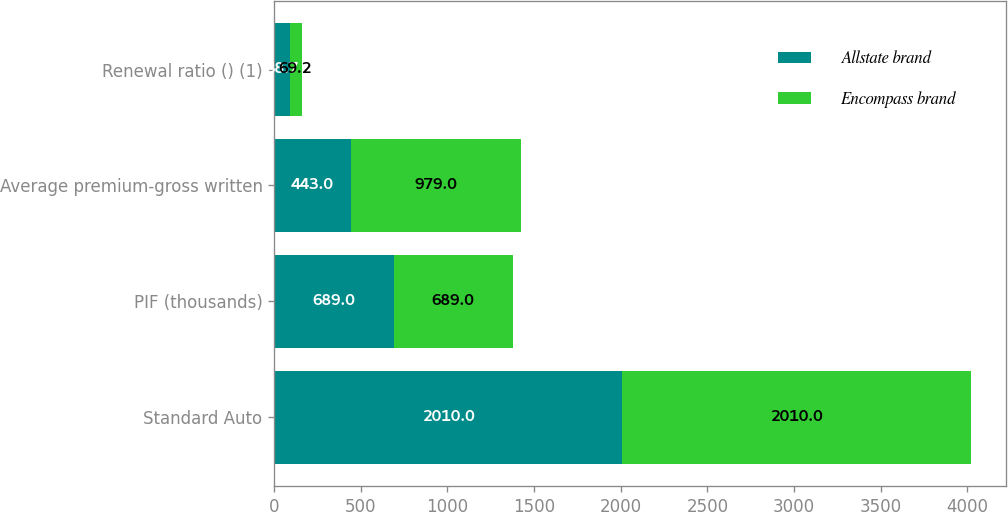<chart> <loc_0><loc_0><loc_500><loc_500><stacked_bar_chart><ecel><fcel>Standard Auto<fcel>PIF (thousands)<fcel>Average premium-gross written<fcel>Renewal ratio () (1)<nl><fcel>Allstate brand<fcel>2010<fcel>689<fcel>443<fcel>88.7<nl><fcel>Encompass brand<fcel>2010<fcel>689<fcel>979<fcel>69.2<nl></chart> 